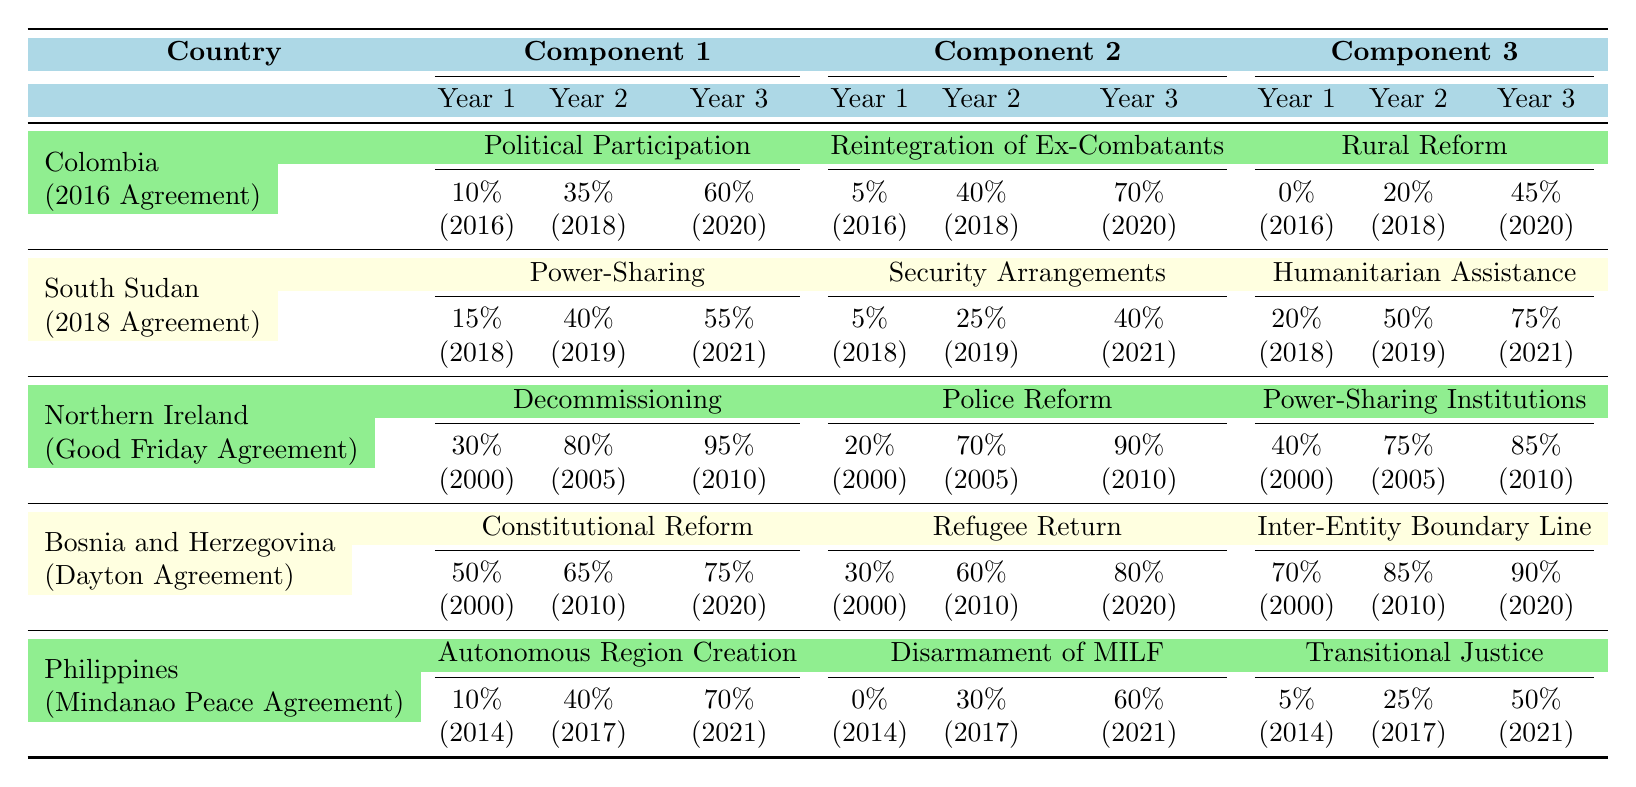What is the implementation percentage of Political Participation in Colombia in 2020? The table shows that the implementation percentage for Political Participation in Colombia in 2020 is 60%.
Answer: 60% What was the percentage of humanitarian assistance in South Sudan in 2018? According to the table, the percentage of humanitarian assistance in South Sudan in 2018 is 20%.
Answer: 20% Which component of the Northern Ireland agreement had the highest implementation percentage in 2010? By comparing the values for 2010, Decommissioning had 95%, which is the highest among the components.
Answer: Decommissioning What is the average implementation percentage for reintegration of ex-combatants in Colombia? The implementation percentages for the years 2016, 2018, and 2020 are 5%, 40%, and 70%, respectively. Sum = (5 + 40 + 70) = 115. To find the average, divide by 3: 115 / 3 = 38.33.
Answer: 38.33% Did the implementation of rural reform in Colombia increase or decrease from 2016 to 2020? The percentages for 2016 and 2020 are 0% and 45%, respectively. Since 0% is less than 45%, the implementation increased.
Answer: Increased What was the total implementation percentage of power-sharing and security arrangements in South Sudan in 2021? In 2021, power-sharing is 55% and security arrangements are 40%. Adding these gives 55 + 40 = 95%.
Answer: 95% In which year did the Philippines see the highest percentage for disarmament of MILF? Looking at the table, the highest percentage for disarmament of MILF in the Philippines is in 2021 at 60%.
Answer: 2021 What is the difference in implementation percentage of constitutional reform between the years 2000 and 2020 in Bosnia and Herzegovina? The percentages for constitutional reform in Bosnia and Herzegovina are 50% in 2000 and 75% in 2020. The difference is 75 - 50 = 25%.
Answer: 25% What component in the Philippine agreement had the lowest implementation in 2014? In 2014, the lowest implementation percentage in the Philippine agreement is for disarmament of MILF at 0%.
Answer: Disarmament of MILF Which country had the highest implementation rates across all components and years combined? By comparing the average values, Bosnia and Herzegovina consistently shows high percentages (averaging above 70%) compared to other countries. Thus, it has the highest overall implementation across components and years.
Answer: Bosnia and Herzegovina 